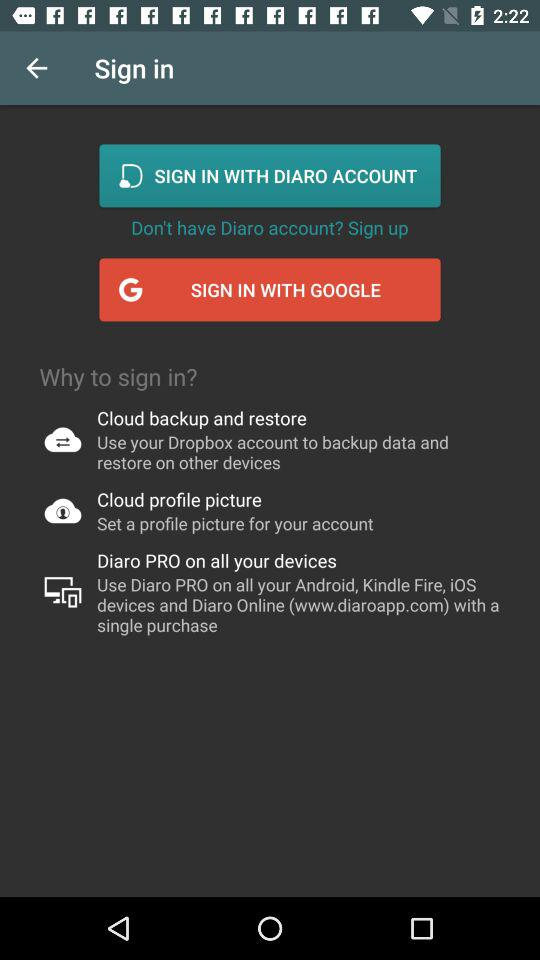What accounts can be used to sign in? The accounts "DIARO" and "GOOGLE" can be used to sign in. 